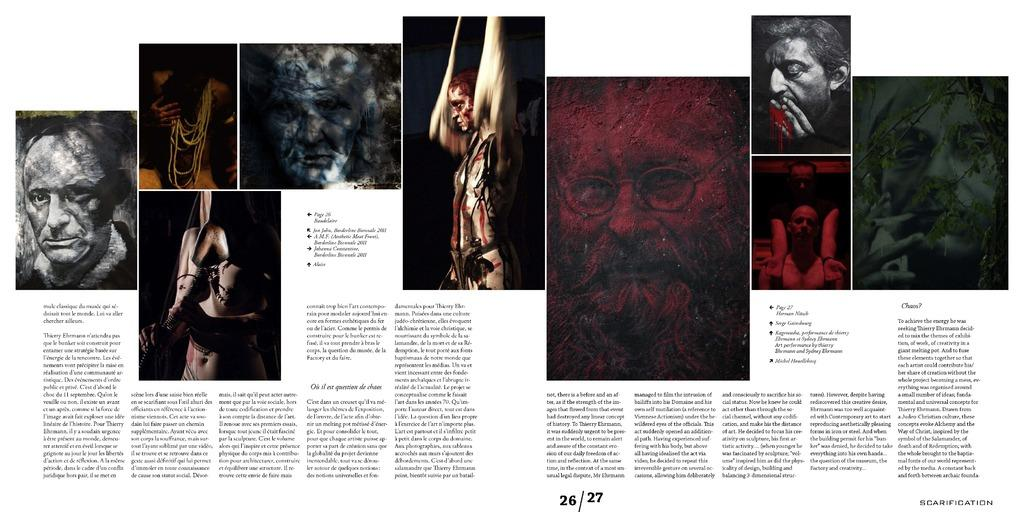What can be seen in the image? There are images of persons and text on a paper in the image. Can you describe the images of persons? The images of persons are not described in detail, but they are present in the image. What is the text on the paper about? The content of the text on the paper is not specified in the facts provided. What type of plastic is visible on the coast in the image? There is no plastic or coast mentioned in the image; it only contains images of persons and text on a paper. 